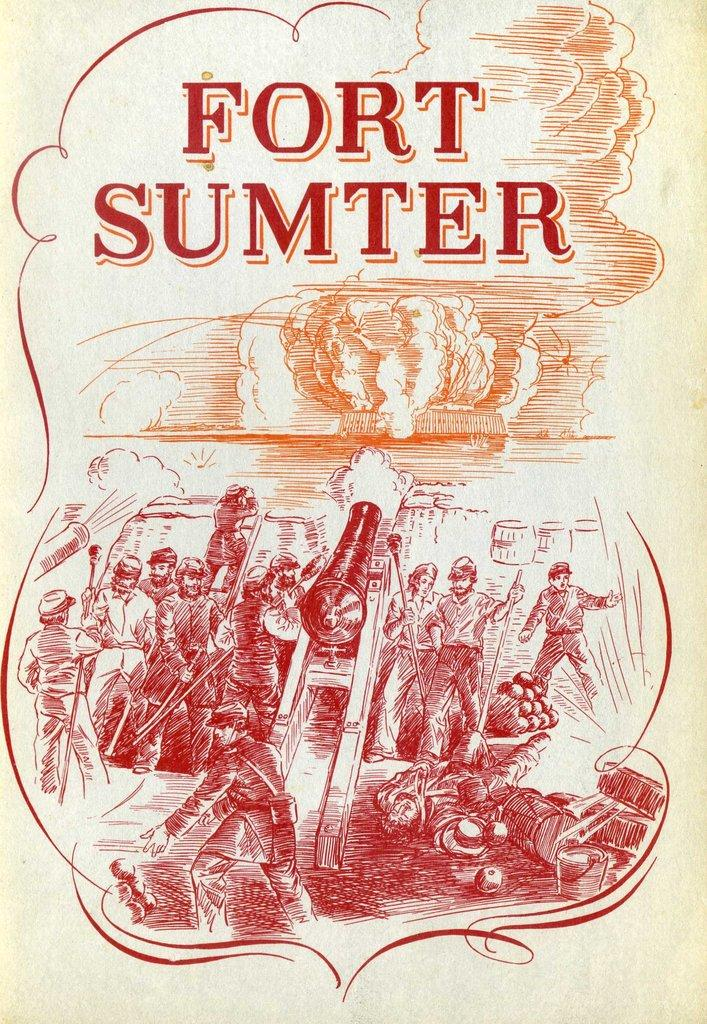<image>
Give a short and clear explanation of the subsequent image. Fort Sumter titles a picture of a battle with a canon. 